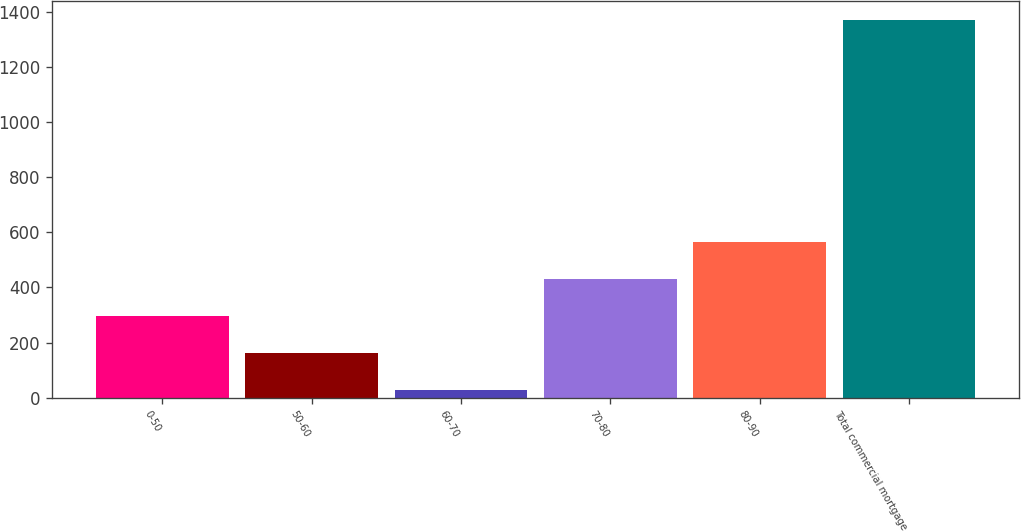Convert chart to OTSL. <chart><loc_0><loc_0><loc_500><loc_500><bar_chart><fcel>0-50<fcel>50-60<fcel>60-70<fcel>70-80<fcel>80-90<fcel>Total commercial mortgage<nl><fcel>296.6<fcel>162.3<fcel>28<fcel>430.9<fcel>565.2<fcel>1371<nl></chart> 